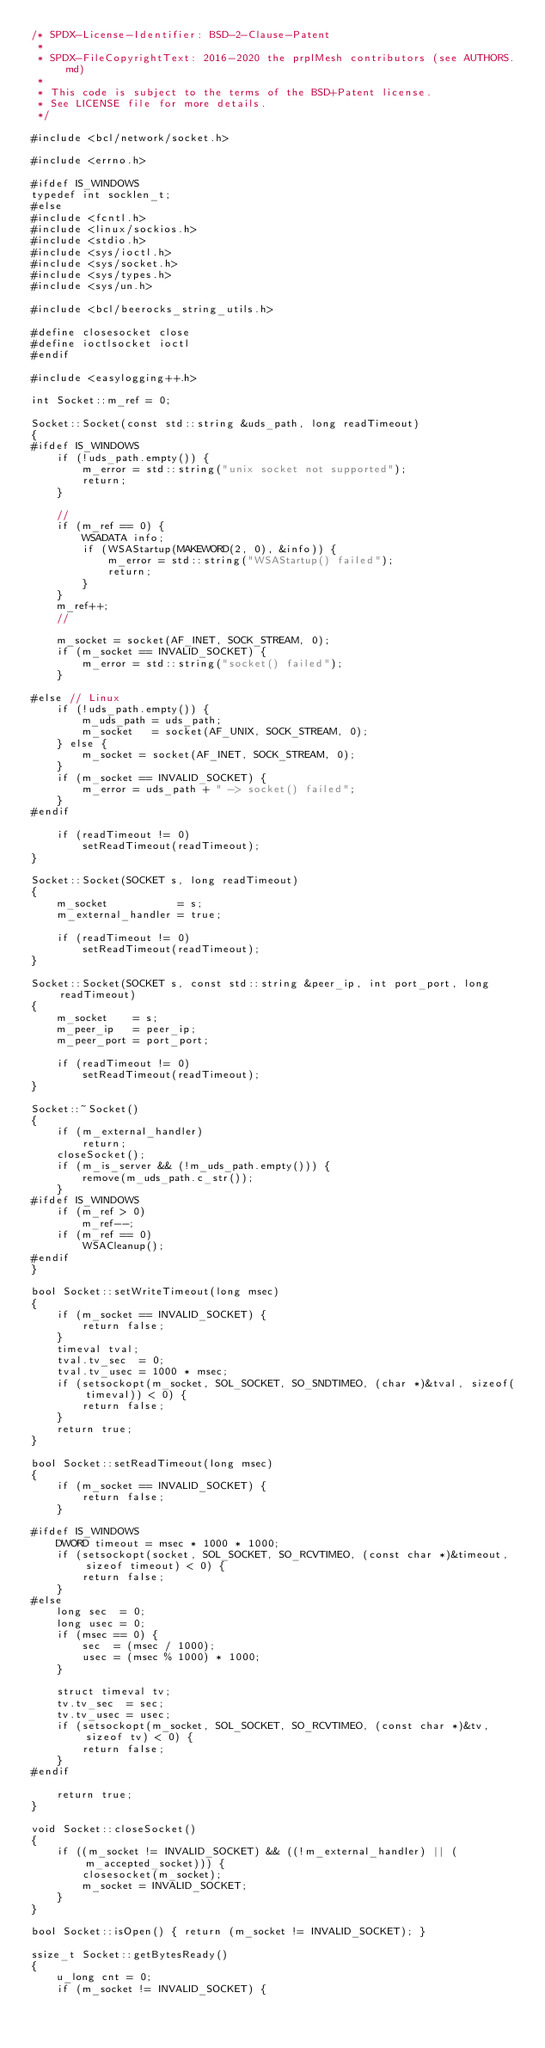<code> <loc_0><loc_0><loc_500><loc_500><_C++_>/* SPDX-License-Identifier: BSD-2-Clause-Patent
 *
 * SPDX-FileCopyrightText: 2016-2020 the prplMesh contributors (see AUTHORS.md)
 *
 * This code is subject to the terms of the BSD+Patent license.
 * See LICENSE file for more details.
 */

#include <bcl/network/socket.h>

#include <errno.h>

#ifdef IS_WINDOWS
typedef int socklen_t;
#else
#include <fcntl.h>
#include <linux/sockios.h>
#include <stdio.h>
#include <sys/ioctl.h>
#include <sys/socket.h>
#include <sys/types.h>
#include <sys/un.h>

#include <bcl/beerocks_string_utils.h>

#define closesocket close
#define ioctlsocket ioctl
#endif

#include <easylogging++.h>

int Socket::m_ref = 0;

Socket::Socket(const std::string &uds_path, long readTimeout)
{
#ifdef IS_WINDOWS
    if (!uds_path.empty()) {
        m_error = std::string("unix socket not supported");
        return;
    }

    //
    if (m_ref == 0) {
        WSADATA info;
        if (WSAStartup(MAKEWORD(2, 0), &info)) {
            m_error = std::string("WSAStartup() failed");
            return;
        }
    }
    m_ref++;
    //

    m_socket = socket(AF_INET, SOCK_STREAM, 0);
    if (m_socket == INVALID_SOCKET) {
        m_error = std::string("socket() failed");
    }

#else // Linux
    if (!uds_path.empty()) {
        m_uds_path = uds_path;
        m_socket   = socket(AF_UNIX, SOCK_STREAM, 0);
    } else {
        m_socket = socket(AF_INET, SOCK_STREAM, 0);
    }
    if (m_socket == INVALID_SOCKET) {
        m_error = uds_path + " -> socket() failed";
    }
#endif

    if (readTimeout != 0)
        setReadTimeout(readTimeout);
}

Socket::Socket(SOCKET s, long readTimeout)
{
    m_socket           = s;
    m_external_handler = true;

    if (readTimeout != 0)
        setReadTimeout(readTimeout);
}

Socket::Socket(SOCKET s, const std::string &peer_ip, int port_port, long readTimeout)
{
    m_socket    = s;
    m_peer_ip   = peer_ip;
    m_peer_port = port_port;

    if (readTimeout != 0)
        setReadTimeout(readTimeout);
}

Socket::~Socket()
{
    if (m_external_handler)
        return;
    closeSocket();
    if (m_is_server && (!m_uds_path.empty())) {
        remove(m_uds_path.c_str());
    }
#ifdef IS_WINDOWS
    if (m_ref > 0)
        m_ref--;
    if (m_ref == 0)
        WSACleanup();
#endif
}

bool Socket::setWriteTimeout(long msec)
{
    if (m_socket == INVALID_SOCKET) {
        return false;
    }
    timeval tval;
    tval.tv_sec  = 0;
    tval.tv_usec = 1000 * msec;
    if (setsockopt(m_socket, SOL_SOCKET, SO_SNDTIMEO, (char *)&tval, sizeof(timeval)) < 0) {
        return false;
    }
    return true;
}

bool Socket::setReadTimeout(long msec)
{
    if (m_socket == INVALID_SOCKET) {
        return false;
    }

#ifdef IS_WINDOWS
    DWORD timeout = msec * 1000 * 1000;
    if (setsockopt(socket, SOL_SOCKET, SO_RCVTIMEO, (const char *)&timeout, sizeof timeout) < 0) {
        return false;
    }
#else
    long sec  = 0;
    long usec = 0;
    if (msec == 0) {
        sec  = (msec / 1000);
        usec = (msec % 1000) * 1000;
    }

    struct timeval tv;
    tv.tv_sec  = sec;
    tv.tv_usec = usec;
    if (setsockopt(m_socket, SOL_SOCKET, SO_RCVTIMEO, (const char *)&tv, sizeof tv) < 0) {
        return false;
    }
#endif

    return true;
}

void Socket::closeSocket()
{
    if ((m_socket != INVALID_SOCKET) && ((!m_external_handler) || (m_accepted_socket))) {
        closesocket(m_socket);
        m_socket = INVALID_SOCKET;
    }
}

bool Socket::isOpen() { return (m_socket != INVALID_SOCKET); }

ssize_t Socket::getBytesReady()
{
    u_long cnt = 0;
    if (m_socket != INVALID_SOCKET) {</code> 